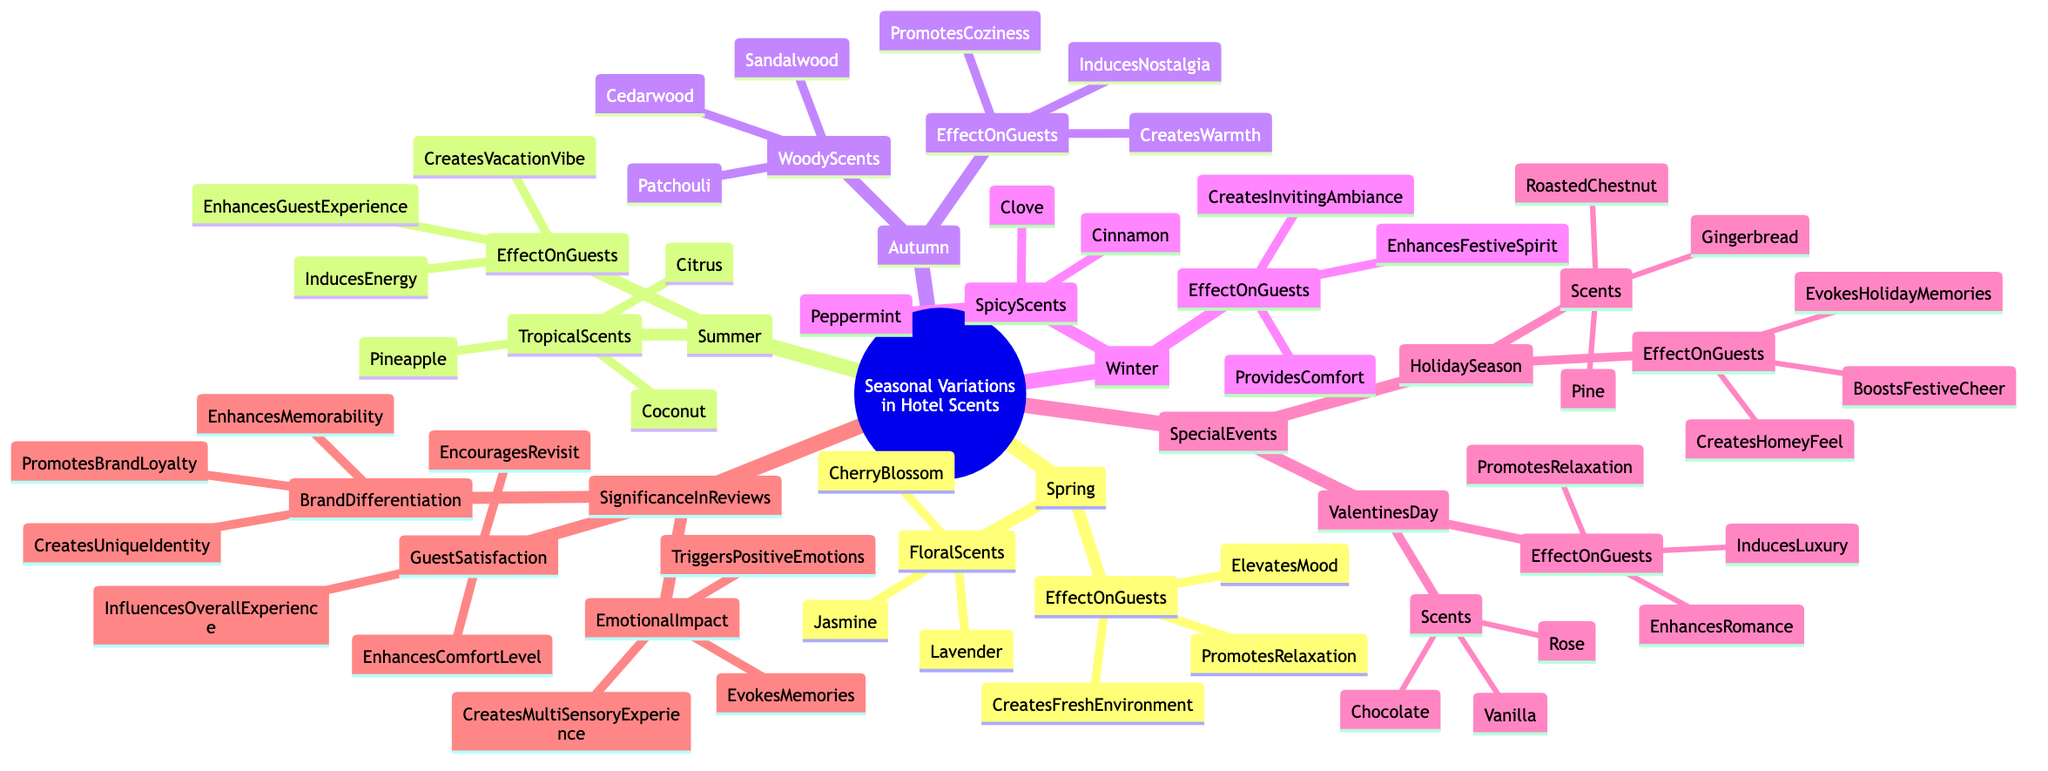What scents are associated with Spring? The diagram lists the Floral Scents under the Spring node, which include Cherry Blossom, Lavender, and Jasmine.
Answer: Cherry Blossom, Lavender, Jasmine How many scents are categorized under Summer? The Summer node has a Tropical Scents section, which includes three scents: Coconut, Citrus, and Pineapple, making a total of three.
Answer: 3 What is one effect of Woody Scents on guests in Autumn? The diagram outlines three effects of Woody Scents on guests under the Autumn node, one of which is "Creates Warmth."
Answer: Creates Warmth Which season features scents like Cinnamon and Clove? From the diagram, the Spicy Scents, including Cinnamon and Clove, are found under the Winter node.
Answer: Winter How do scents during the Holiday Season impact guests? The Special Events section under Holiday Season lists three effects on guests: Boosts Festive Cheer, Evokes Holiday Memories, and Creates a Homey Feel.
Answer: Boosts Festive Cheer Which node describes the emotional impact of scents? The diagram indicates that the Emotional Impact is part of the Significance of Scents in Reviews node.
Answer: Significance of Scents in Reviews What scent is associated with Valentine's Day? From the Special Events section, the Valentine’s Day node includes the scents: Rose, Chocolate, and Vanilla.
Answer: Rose, Chocolate, Vanilla What is the relationship between Brand Differentiation and Guest Satisfaction? Both Brand Differentiation and Guest Satisfaction are parts of the Significance of Scents in Reviews, indicating that scents can impact both guest experience and brand loyalty, thus they are related in enhancing overall review significance.
Answer: Related Which scent from Summer induces energy? The Summer effects include "Induces Energy" which is attributed to the Tropical Scents like Coconut, Citrus, and Pineapple.
Answer: Induces Energy 